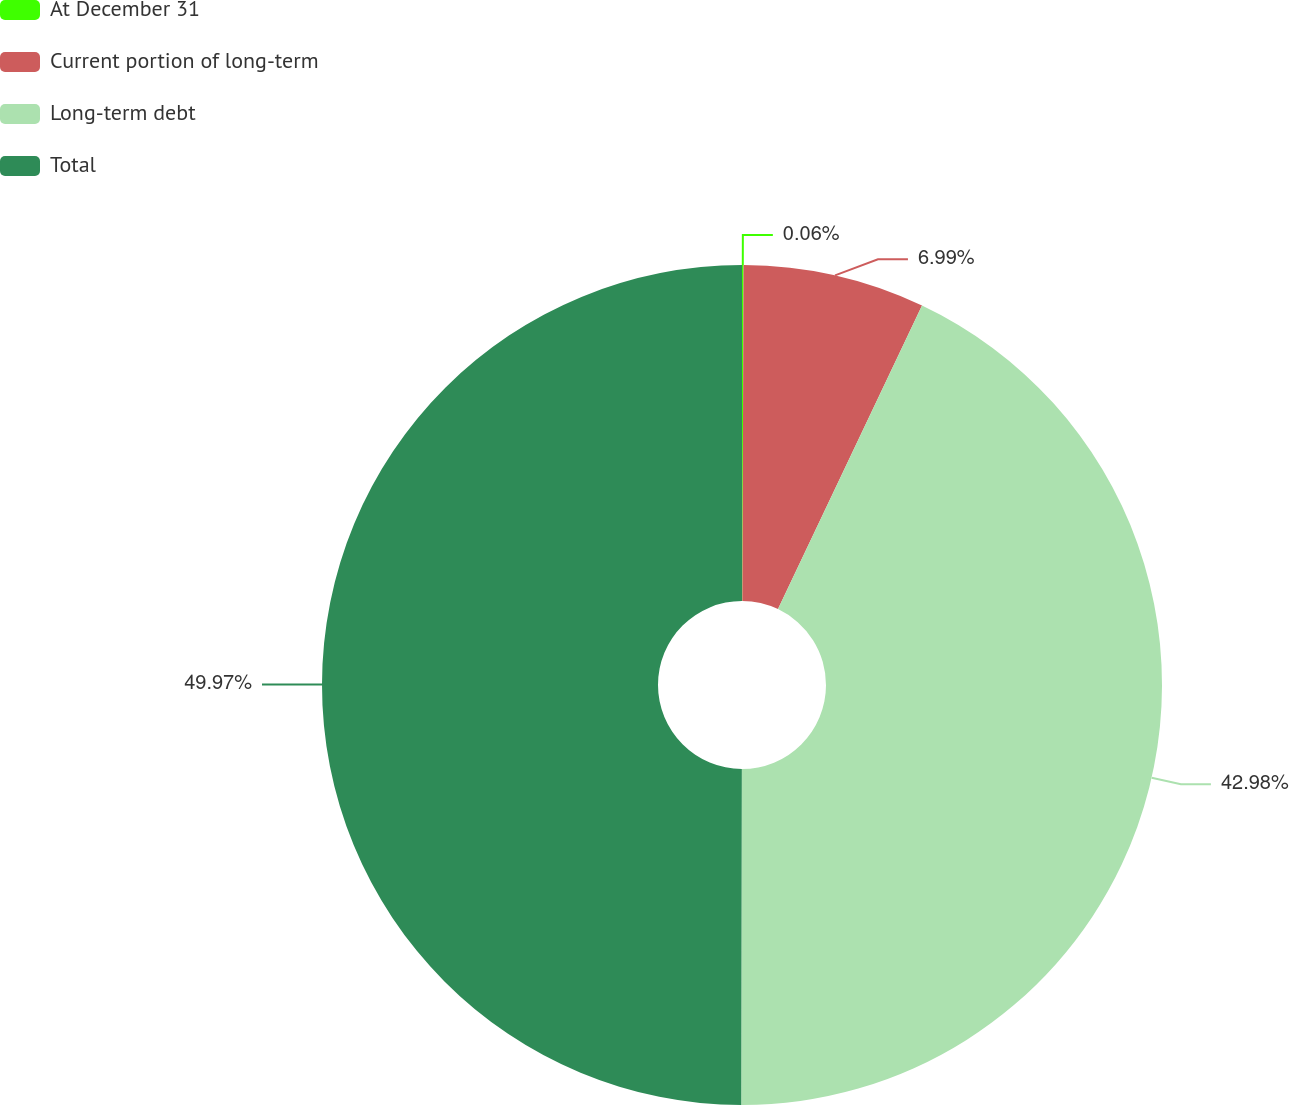Convert chart. <chart><loc_0><loc_0><loc_500><loc_500><pie_chart><fcel>At December 31<fcel>Current portion of long-term<fcel>Long-term debt<fcel>Total<nl><fcel>0.06%<fcel>6.99%<fcel>42.98%<fcel>49.97%<nl></chart> 